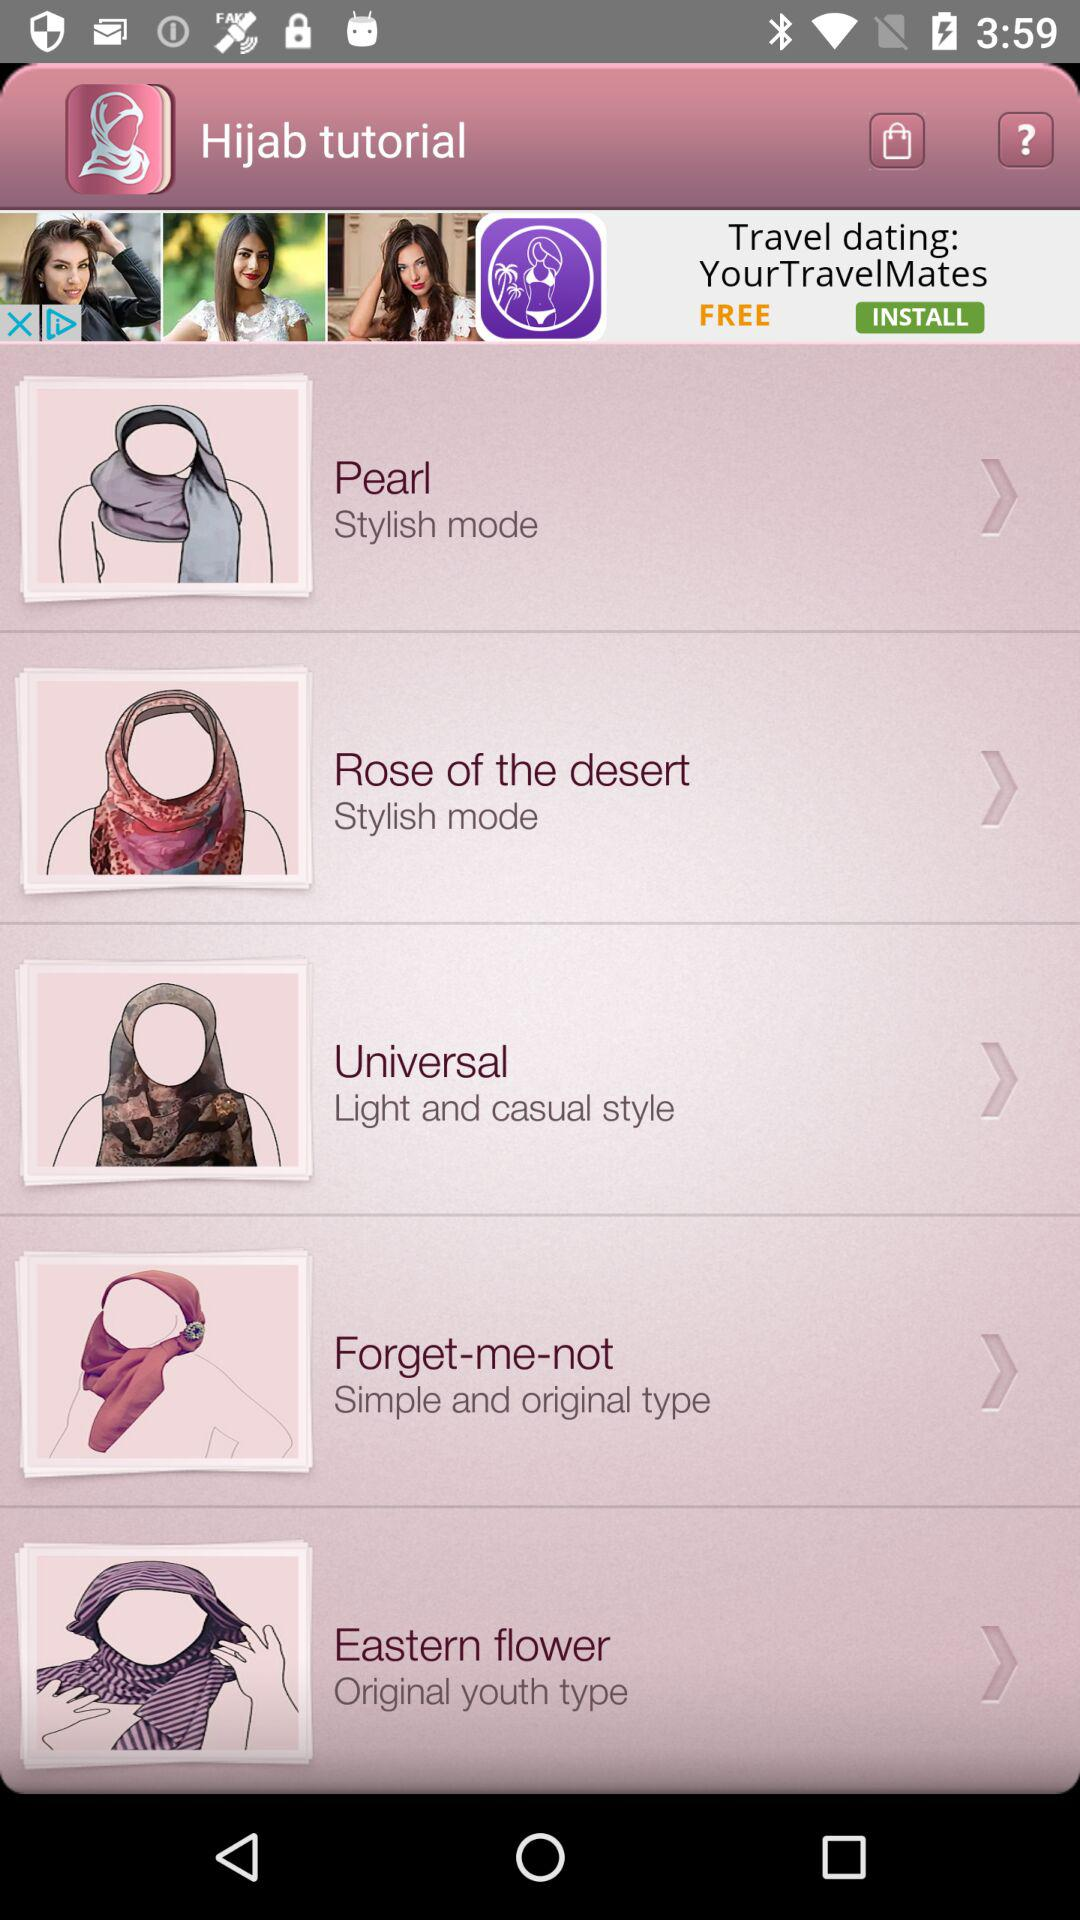Which hijab is the simple and original type? The simple and original type of hijab is the "Forget-me-not". 